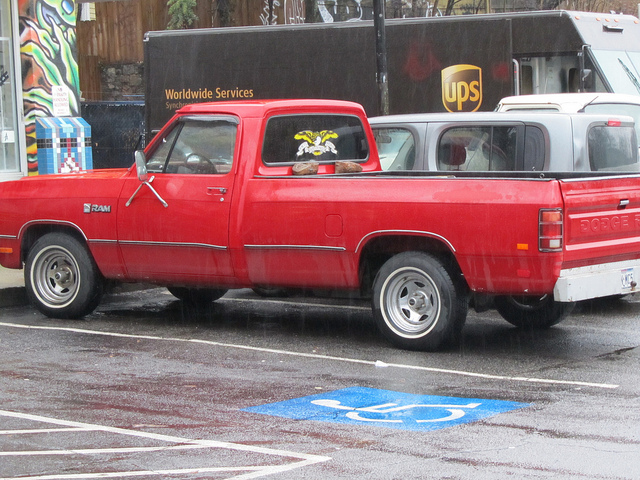<image>What does his window decal indicate? I don't know what his window decal indicates. It could possibly indicate 'military', 'angels', 'bee' or 'hockey'. What does his window decal indicate? I don't know what his window decal indicates. It can be angels, bee, decoration, military, eagle, motorcyclist, hockey, or army. 